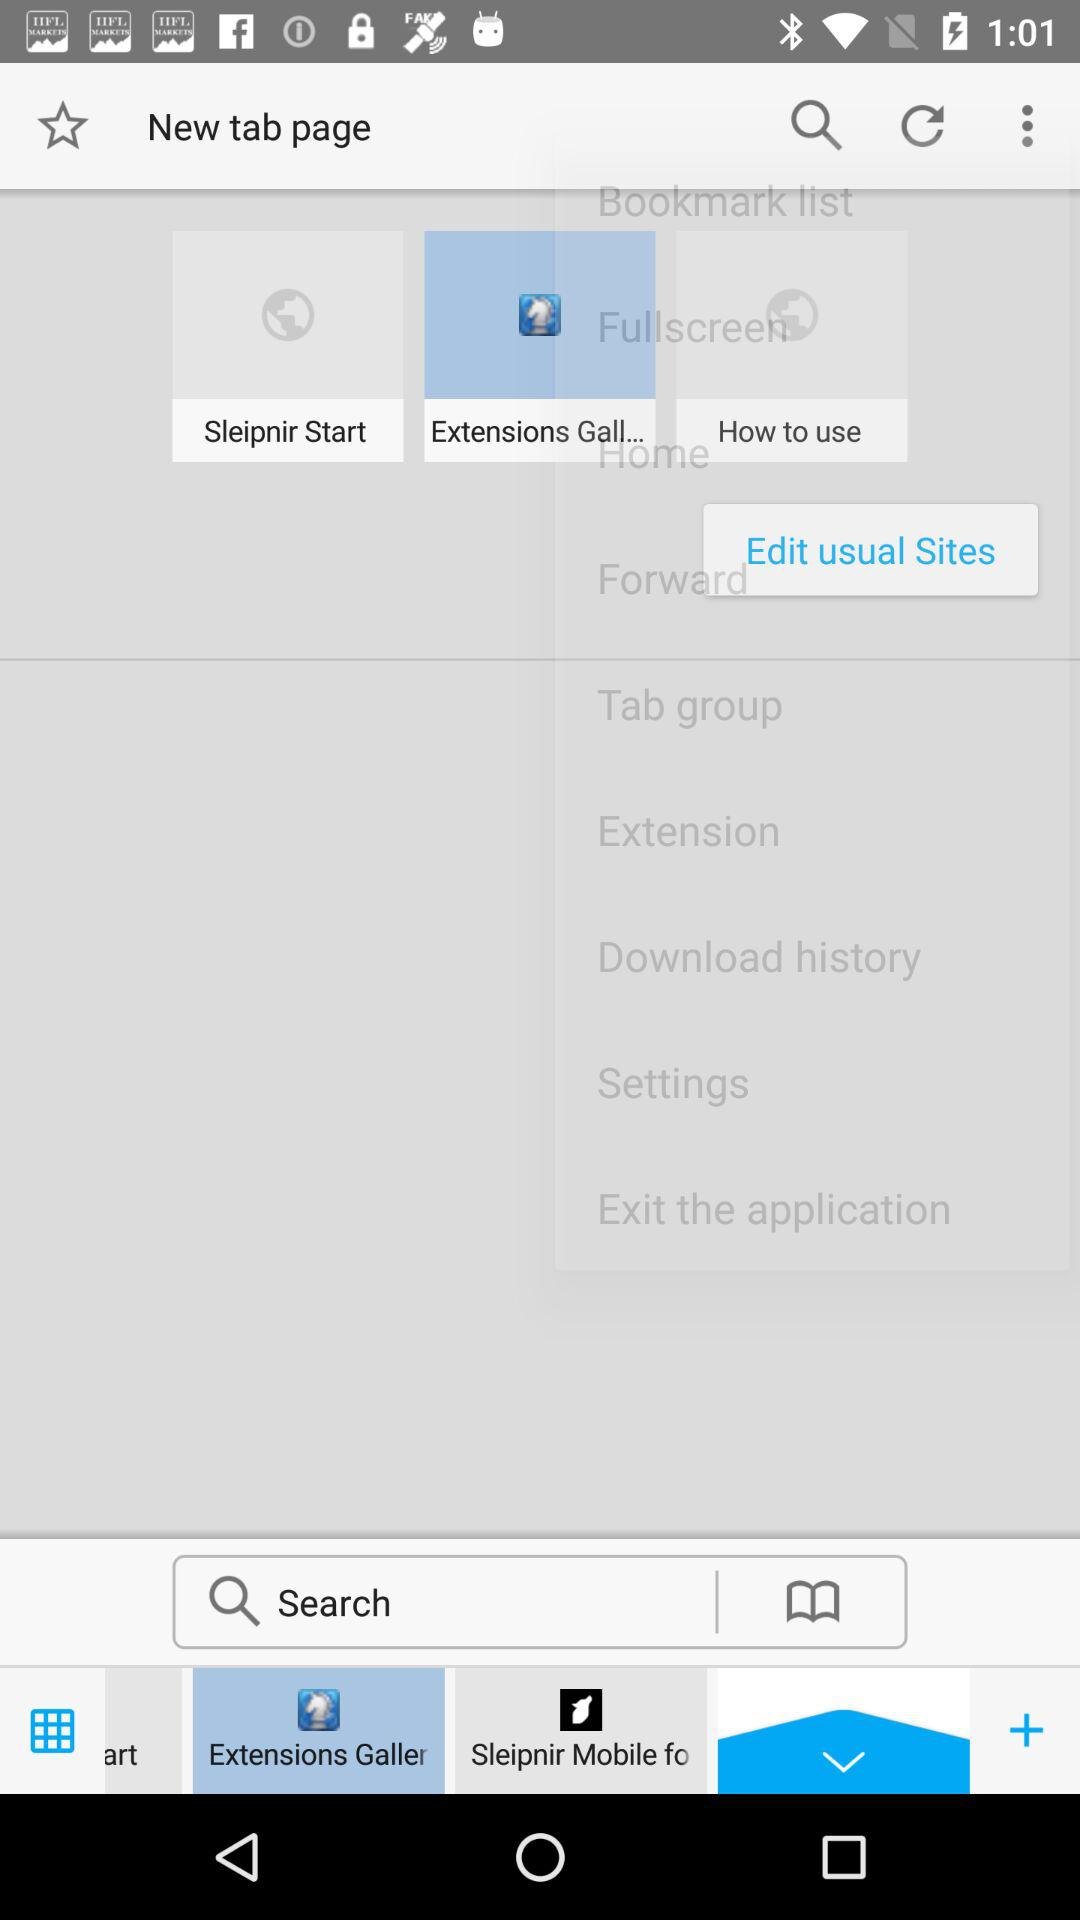Which tab is currently selected at the bottom?
When the provided information is insufficient, respond with <no answer>. <no answer> 